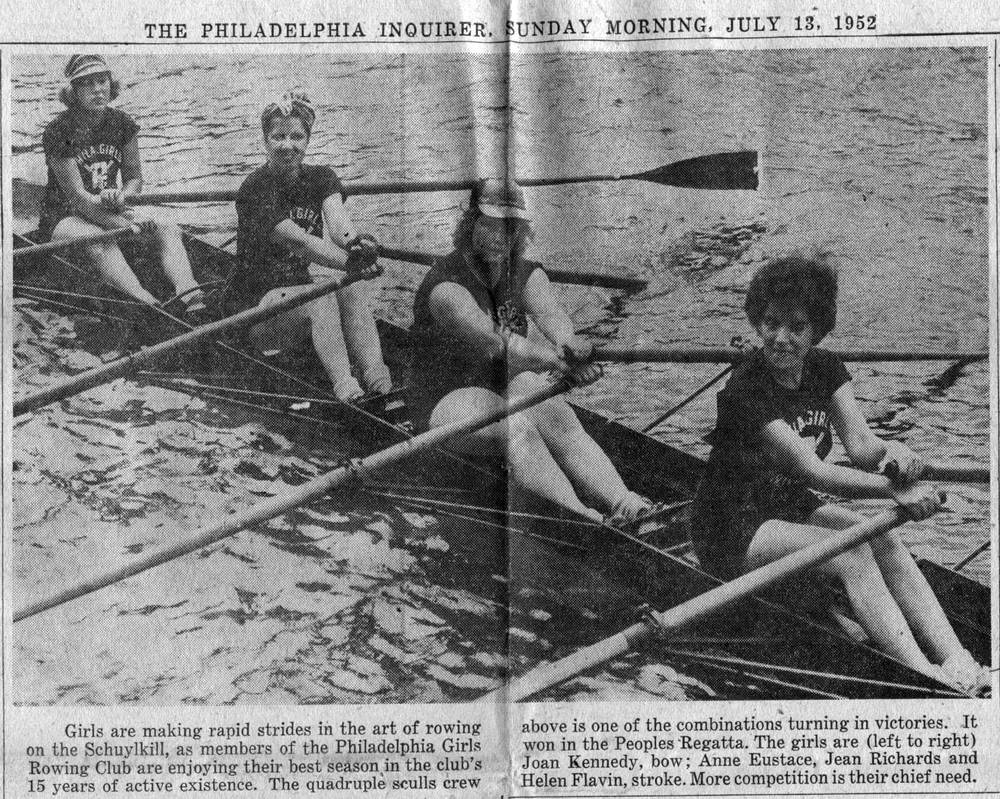How does the era in which this photo was taken influence the perception of these athletes and their sport? This photo, with the attire and equipment indicative of the 1950s, portrays these athletes as pioneers in their field, especially given the historical context of women's sports. Their participation in competitive rowing challenges the traditional gender norms of the time, highlighting their contribution to the evolution of women's athletics. 